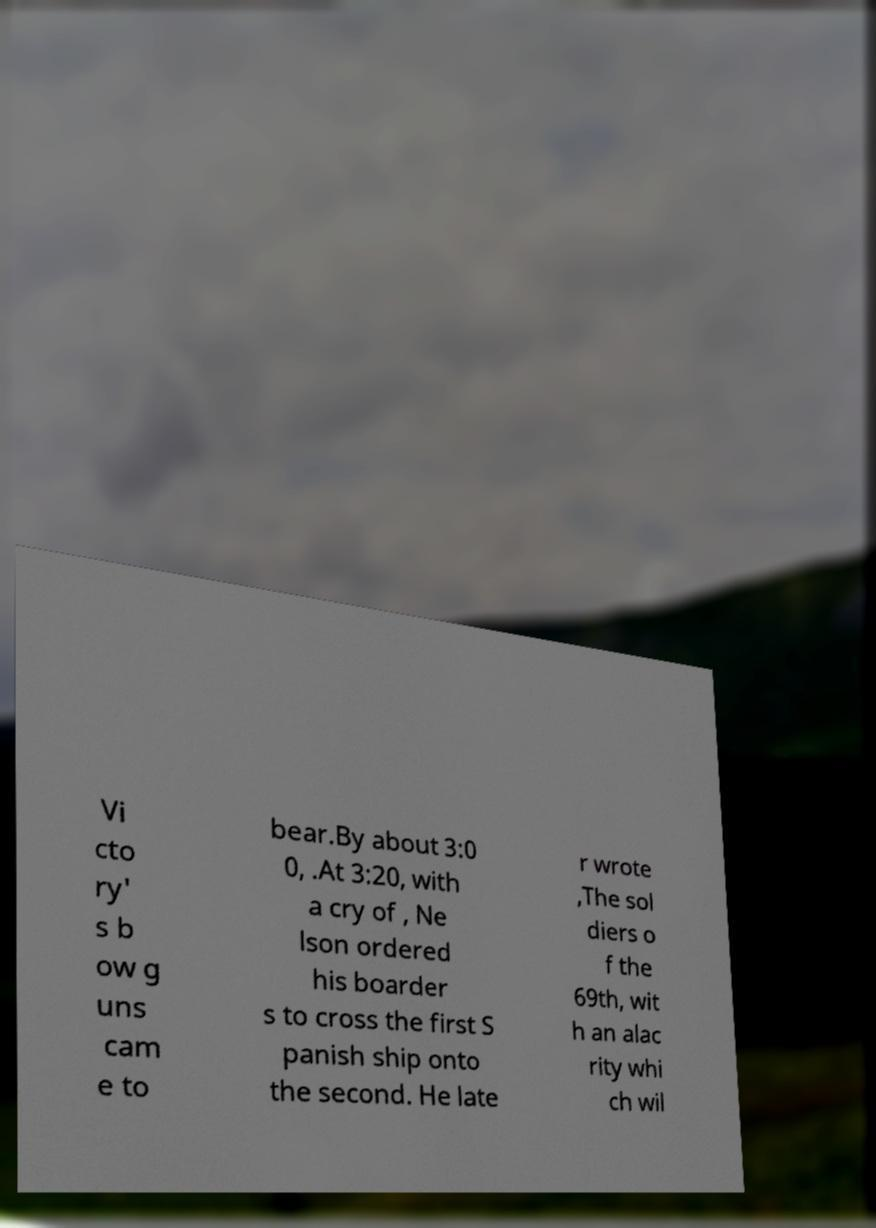For documentation purposes, I need the text within this image transcribed. Could you provide that? Vi cto ry' s b ow g uns cam e to bear.By about 3:0 0, .At 3:20, with a cry of , Ne lson ordered his boarder s to cross the first S panish ship onto the second. He late r wrote ,The sol diers o f the 69th, wit h an alac rity whi ch wil 